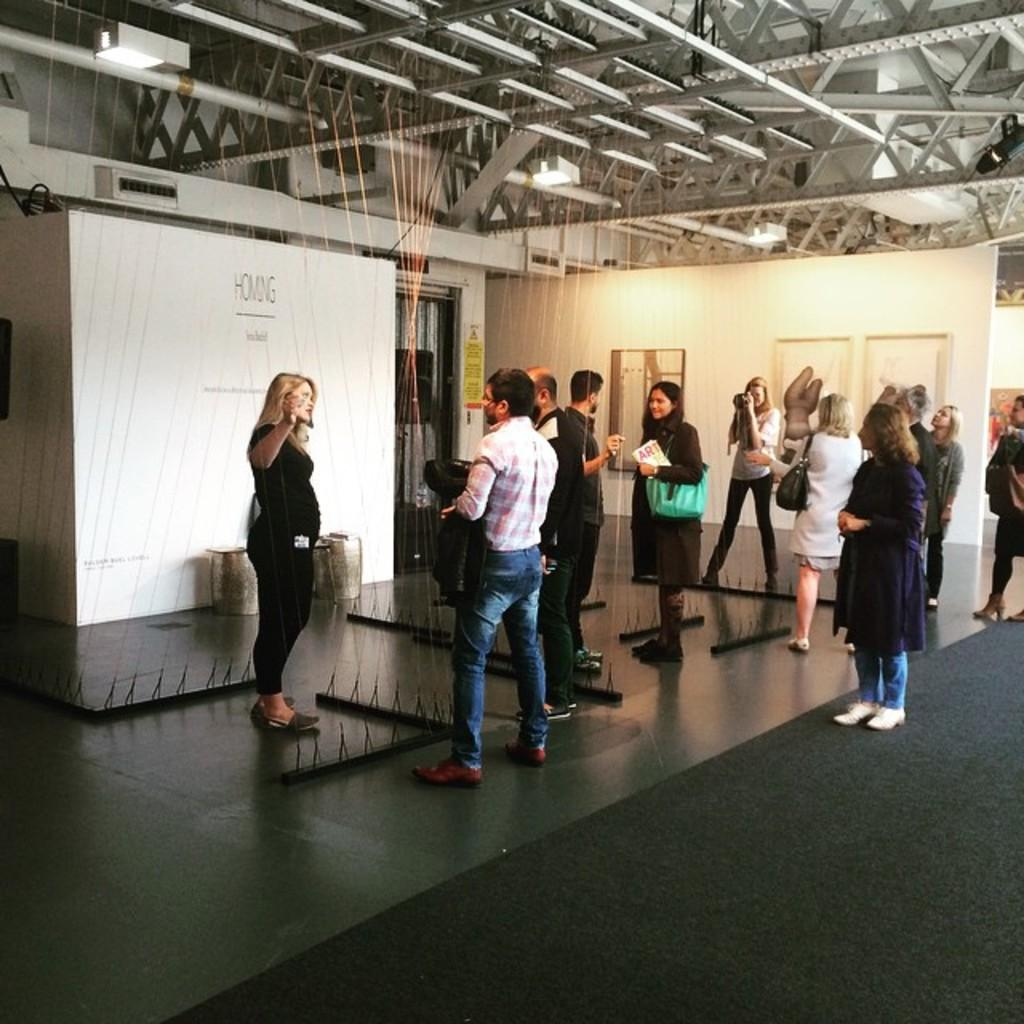How many people are in the image? There is a group of people standing in the image, but the exact number cannot be determined from the provided facts. What is located in the background of the image? There is a board and lights visible in the background of the image. What else can be seen in the background of the image? There are poles in the background of the image. What type of bean is growing on the board in the image? There is no bean present in the image, and the board does not appear to be a surface for growing plants. 